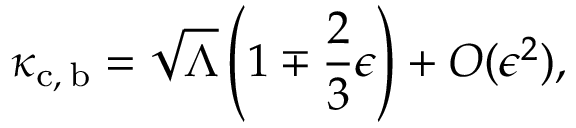<formula> <loc_0><loc_0><loc_500><loc_500>\kappa _ { c , \, b } = \sqrt { \Lambda } \left ( 1 \mp \frac { 2 } { 3 } \epsilon \right ) + O ( \epsilon ^ { 2 } ) ,</formula> 